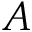Convert formula to latex. <formula><loc_0><loc_0><loc_500><loc_500>A</formula> 